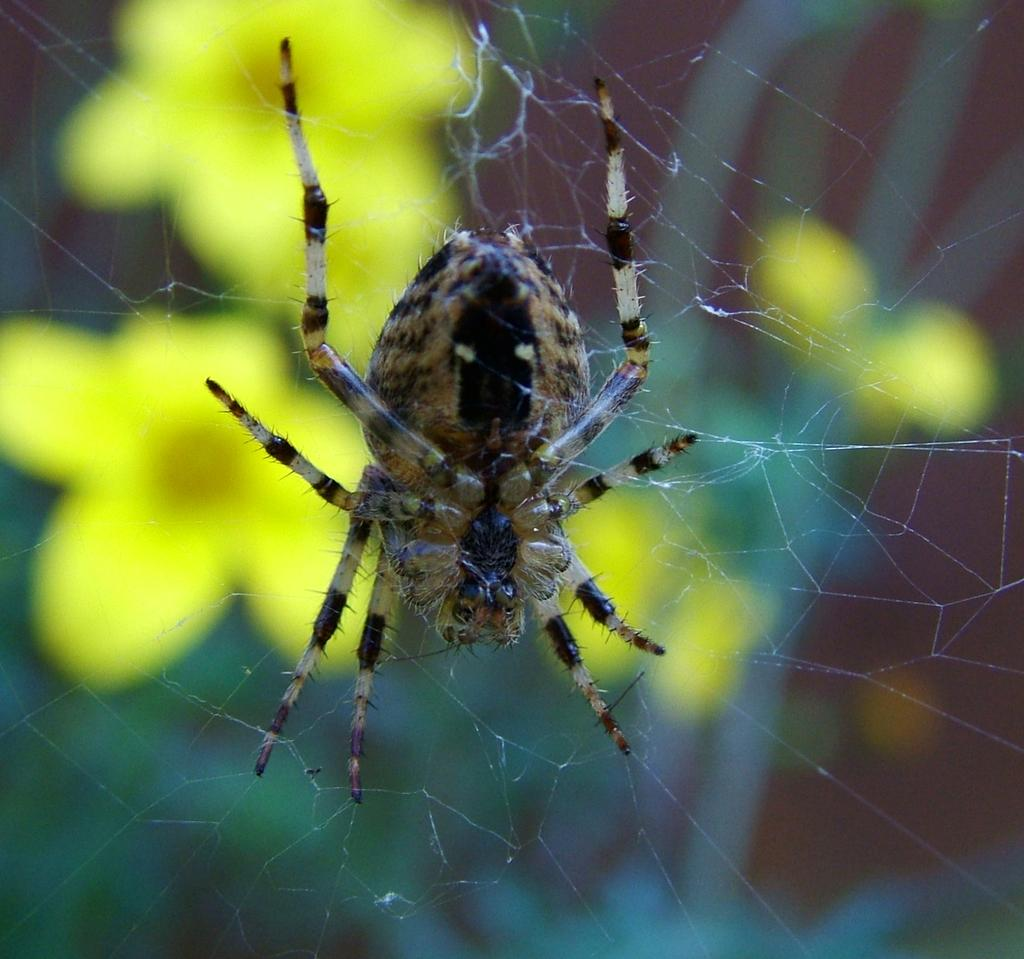What is located in the center of the image? There is an insect in the web in the center of the image. What can be seen in the background of the image? There are flowers in the background of the image. What type of answer is the insect providing in the image? The insect is not providing any answer in the image; it is simply caught in the web. What type of shirt is the insect wearing in the image? The insect is not wearing a shirt in the image, as insects do not wear clothing. 